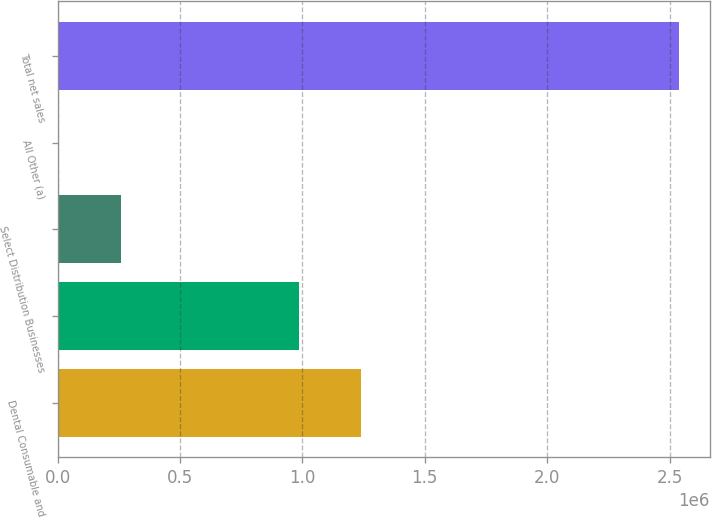<chart> <loc_0><loc_0><loc_500><loc_500><bar_chart><fcel>Dental Consumable and<fcel>Unnamed: 1<fcel>Select Distribution Businesses<fcel>All Other (a)<fcel>Total net sales<nl><fcel>1.24105e+06<fcel>987778<fcel>258299<fcel>5030<fcel>2.53772e+06<nl></chart> 